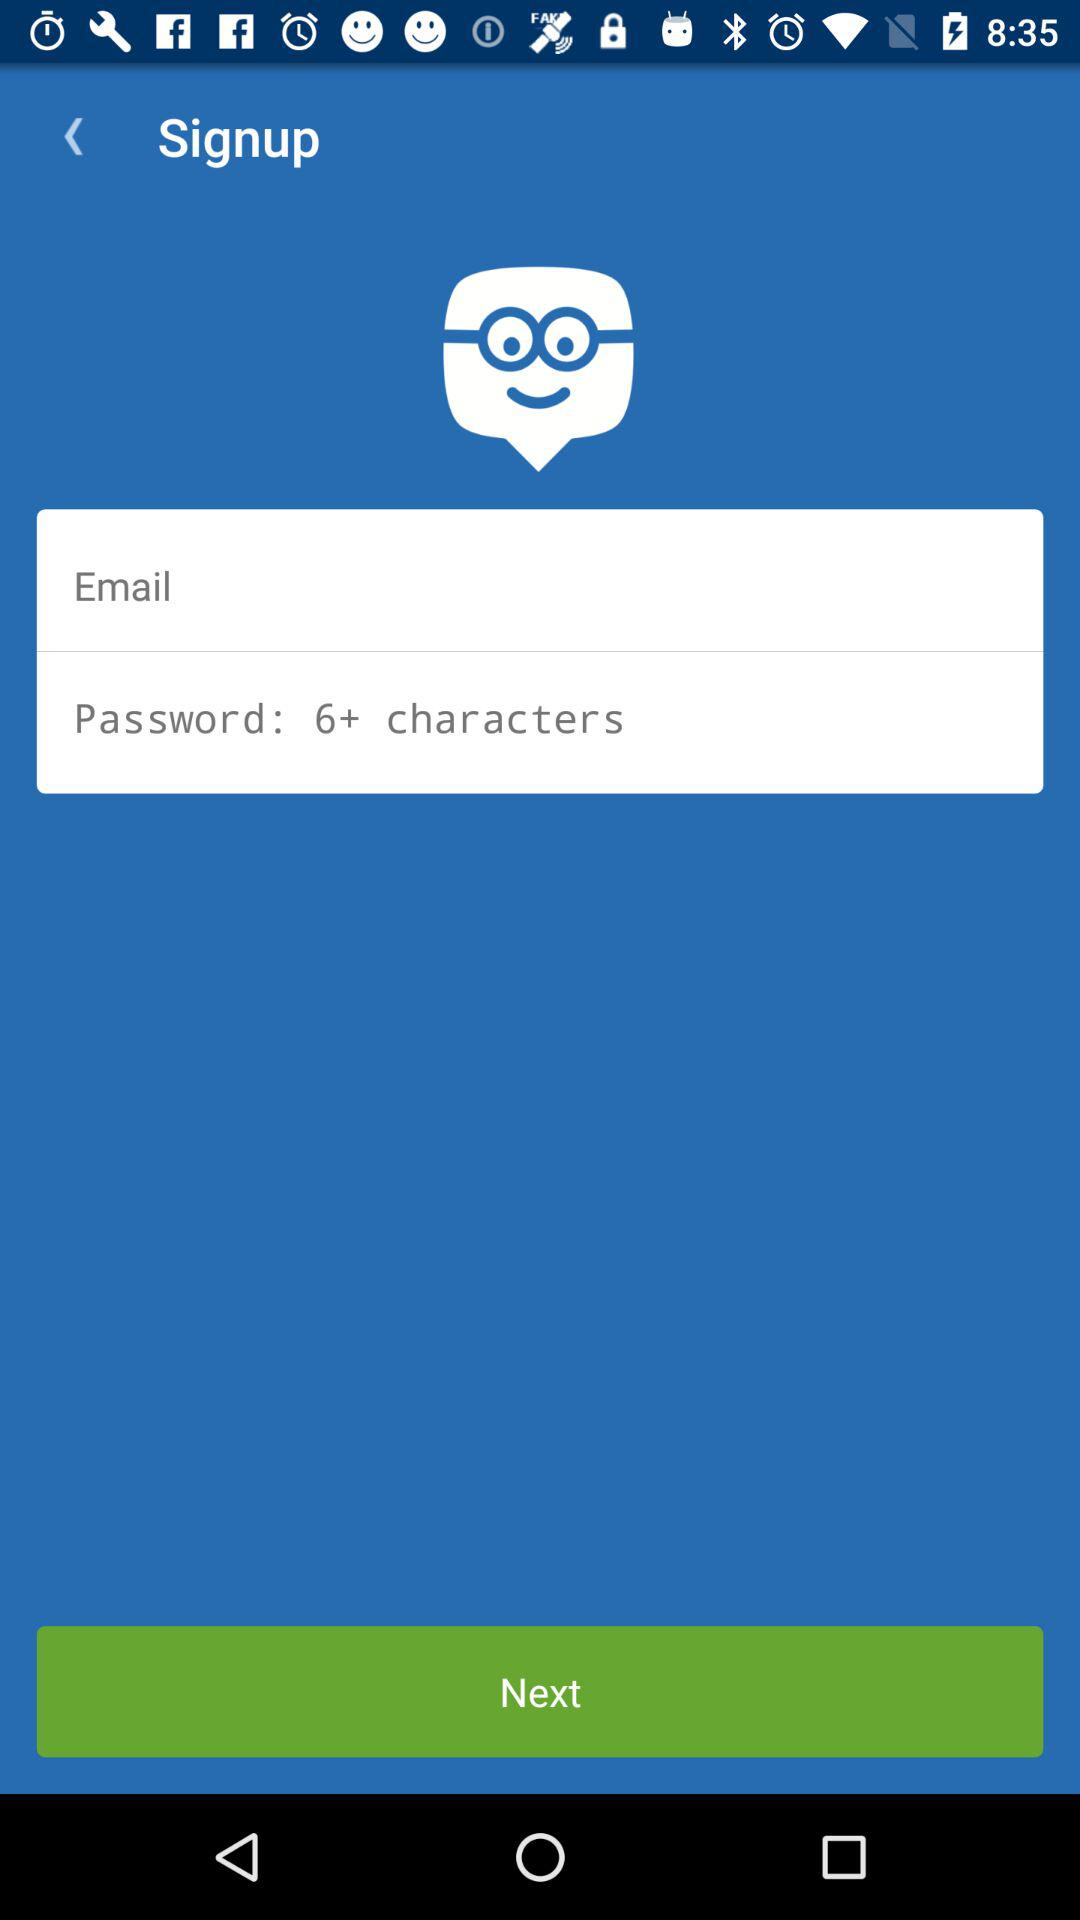How many fields are there in the signup form?
Answer the question using a single word or phrase. 2 